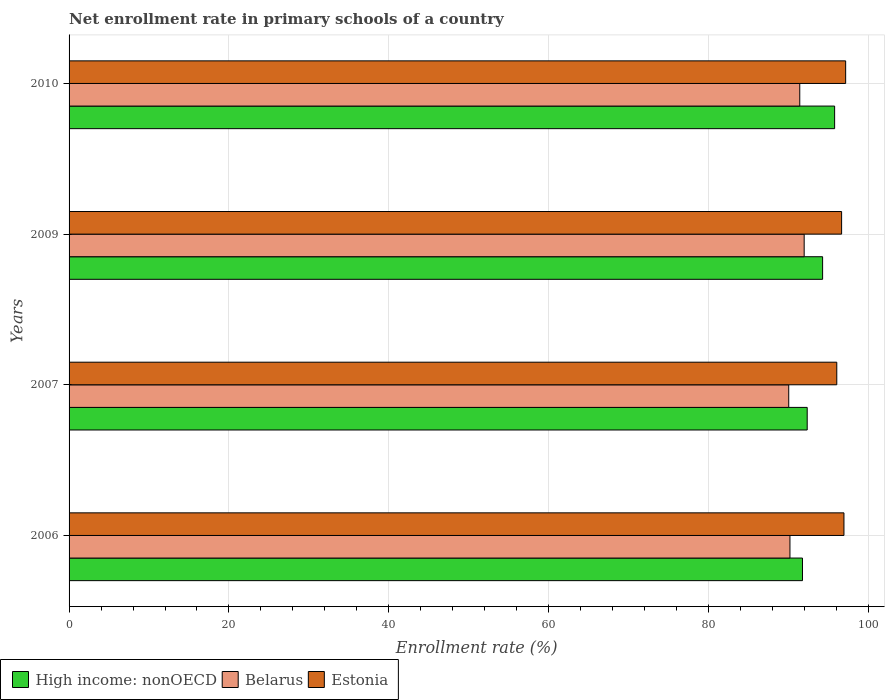Are the number of bars per tick equal to the number of legend labels?
Your response must be concise. Yes. How many bars are there on the 2nd tick from the bottom?
Give a very brief answer. 3. What is the label of the 3rd group of bars from the top?
Give a very brief answer. 2007. In how many cases, is the number of bars for a given year not equal to the number of legend labels?
Ensure brevity in your answer.  0. What is the enrollment rate in primary schools in Estonia in 2006?
Provide a short and direct response. 96.94. Across all years, what is the maximum enrollment rate in primary schools in Belarus?
Give a very brief answer. 91.96. Across all years, what is the minimum enrollment rate in primary schools in High income: nonOECD?
Make the answer very short. 91.75. In which year was the enrollment rate in primary schools in High income: nonOECD maximum?
Ensure brevity in your answer.  2010. In which year was the enrollment rate in primary schools in Belarus minimum?
Provide a succinct answer. 2007. What is the total enrollment rate in primary schools in Estonia in the graph?
Give a very brief answer. 386.77. What is the difference between the enrollment rate in primary schools in Belarus in 2006 and that in 2007?
Your response must be concise. 0.15. What is the difference between the enrollment rate in primary schools in Estonia in 2006 and the enrollment rate in primary schools in High income: nonOECD in 2010?
Ensure brevity in your answer.  1.17. What is the average enrollment rate in primary schools in High income: nonOECD per year?
Give a very brief answer. 93.53. In the year 2010, what is the difference between the enrollment rate in primary schools in Estonia and enrollment rate in primary schools in Belarus?
Provide a succinct answer. 5.74. What is the ratio of the enrollment rate in primary schools in Estonia in 2007 to that in 2009?
Ensure brevity in your answer.  0.99. What is the difference between the highest and the second highest enrollment rate in primary schools in High income: nonOECD?
Your answer should be very brief. 1.5. What is the difference between the highest and the lowest enrollment rate in primary schools in High income: nonOECD?
Offer a very short reply. 4.02. Is the sum of the enrollment rate in primary schools in High income: nonOECD in 2006 and 2007 greater than the maximum enrollment rate in primary schools in Belarus across all years?
Give a very brief answer. Yes. What does the 1st bar from the top in 2009 represents?
Provide a succinct answer. Estonia. What does the 1st bar from the bottom in 2010 represents?
Your answer should be compact. High income: nonOECD. Is it the case that in every year, the sum of the enrollment rate in primary schools in Belarus and enrollment rate in primary schools in High income: nonOECD is greater than the enrollment rate in primary schools in Estonia?
Provide a short and direct response. Yes. How many bars are there?
Your answer should be compact. 12. Are all the bars in the graph horizontal?
Give a very brief answer. Yes. Does the graph contain grids?
Provide a short and direct response. Yes. How many legend labels are there?
Give a very brief answer. 3. What is the title of the graph?
Your answer should be compact. Net enrollment rate in primary schools of a country. Does "Northern Mariana Islands" appear as one of the legend labels in the graph?
Offer a terse response. No. What is the label or title of the X-axis?
Ensure brevity in your answer.  Enrollment rate (%). What is the Enrollment rate (%) in High income: nonOECD in 2006?
Offer a very short reply. 91.75. What is the Enrollment rate (%) in Belarus in 2006?
Make the answer very short. 90.18. What is the Enrollment rate (%) of Estonia in 2006?
Your answer should be very brief. 96.94. What is the Enrollment rate (%) in High income: nonOECD in 2007?
Offer a terse response. 92.34. What is the Enrollment rate (%) of Belarus in 2007?
Provide a succinct answer. 90.03. What is the Enrollment rate (%) in Estonia in 2007?
Your answer should be very brief. 96.04. What is the Enrollment rate (%) of High income: nonOECD in 2009?
Ensure brevity in your answer.  94.27. What is the Enrollment rate (%) in Belarus in 2009?
Make the answer very short. 91.96. What is the Enrollment rate (%) in Estonia in 2009?
Make the answer very short. 96.64. What is the Enrollment rate (%) in High income: nonOECD in 2010?
Your answer should be very brief. 95.77. What is the Enrollment rate (%) in Belarus in 2010?
Offer a terse response. 91.41. What is the Enrollment rate (%) of Estonia in 2010?
Your answer should be very brief. 97.15. Across all years, what is the maximum Enrollment rate (%) of High income: nonOECD?
Offer a terse response. 95.77. Across all years, what is the maximum Enrollment rate (%) in Belarus?
Your response must be concise. 91.96. Across all years, what is the maximum Enrollment rate (%) of Estonia?
Your response must be concise. 97.15. Across all years, what is the minimum Enrollment rate (%) in High income: nonOECD?
Your answer should be very brief. 91.75. Across all years, what is the minimum Enrollment rate (%) in Belarus?
Keep it short and to the point. 90.03. Across all years, what is the minimum Enrollment rate (%) of Estonia?
Your answer should be very brief. 96.04. What is the total Enrollment rate (%) in High income: nonOECD in the graph?
Ensure brevity in your answer.  374.12. What is the total Enrollment rate (%) of Belarus in the graph?
Keep it short and to the point. 363.58. What is the total Enrollment rate (%) in Estonia in the graph?
Give a very brief answer. 386.77. What is the difference between the Enrollment rate (%) of High income: nonOECD in 2006 and that in 2007?
Make the answer very short. -0.59. What is the difference between the Enrollment rate (%) of Belarus in 2006 and that in 2007?
Keep it short and to the point. 0.15. What is the difference between the Enrollment rate (%) of Estonia in 2006 and that in 2007?
Keep it short and to the point. 0.9. What is the difference between the Enrollment rate (%) of High income: nonOECD in 2006 and that in 2009?
Offer a terse response. -2.52. What is the difference between the Enrollment rate (%) of Belarus in 2006 and that in 2009?
Provide a short and direct response. -1.78. What is the difference between the Enrollment rate (%) of Estonia in 2006 and that in 2009?
Provide a succinct answer. 0.29. What is the difference between the Enrollment rate (%) in High income: nonOECD in 2006 and that in 2010?
Your answer should be very brief. -4.02. What is the difference between the Enrollment rate (%) in Belarus in 2006 and that in 2010?
Make the answer very short. -1.23. What is the difference between the Enrollment rate (%) of Estonia in 2006 and that in 2010?
Your response must be concise. -0.21. What is the difference between the Enrollment rate (%) in High income: nonOECD in 2007 and that in 2009?
Offer a terse response. -1.93. What is the difference between the Enrollment rate (%) in Belarus in 2007 and that in 2009?
Your answer should be very brief. -1.93. What is the difference between the Enrollment rate (%) of Estonia in 2007 and that in 2009?
Your answer should be compact. -0.6. What is the difference between the Enrollment rate (%) of High income: nonOECD in 2007 and that in 2010?
Your response must be concise. -3.43. What is the difference between the Enrollment rate (%) in Belarus in 2007 and that in 2010?
Keep it short and to the point. -1.38. What is the difference between the Enrollment rate (%) in Estonia in 2007 and that in 2010?
Make the answer very short. -1.11. What is the difference between the Enrollment rate (%) of High income: nonOECD in 2009 and that in 2010?
Give a very brief answer. -1.5. What is the difference between the Enrollment rate (%) in Belarus in 2009 and that in 2010?
Your response must be concise. 0.55. What is the difference between the Enrollment rate (%) of Estonia in 2009 and that in 2010?
Keep it short and to the point. -0.51. What is the difference between the Enrollment rate (%) in High income: nonOECD in 2006 and the Enrollment rate (%) in Belarus in 2007?
Your answer should be very brief. 1.72. What is the difference between the Enrollment rate (%) in High income: nonOECD in 2006 and the Enrollment rate (%) in Estonia in 2007?
Make the answer very short. -4.29. What is the difference between the Enrollment rate (%) in Belarus in 2006 and the Enrollment rate (%) in Estonia in 2007?
Your answer should be compact. -5.86. What is the difference between the Enrollment rate (%) in High income: nonOECD in 2006 and the Enrollment rate (%) in Belarus in 2009?
Offer a very short reply. -0.21. What is the difference between the Enrollment rate (%) of High income: nonOECD in 2006 and the Enrollment rate (%) of Estonia in 2009?
Provide a short and direct response. -4.89. What is the difference between the Enrollment rate (%) of Belarus in 2006 and the Enrollment rate (%) of Estonia in 2009?
Provide a succinct answer. -6.46. What is the difference between the Enrollment rate (%) in High income: nonOECD in 2006 and the Enrollment rate (%) in Belarus in 2010?
Your response must be concise. 0.34. What is the difference between the Enrollment rate (%) of High income: nonOECD in 2006 and the Enrollment rate (%) of Estonia in 2010?
Give a very brief answer. -5.4. What is the difference between the Enrollment rate (%) in Belarus in 2006 and the Enrollment rate (%) in Estonia in 2010?
Keep it short and to the point. -6.97. What is the difference between the Enrollment rate (%) of High income: nonOECD in 2007 and the Enrollment rate (%) of Belarus in 2009?
Your answer should be very brief. 0.38. What is the difference between the Enrollment rate (%) of High income: nonOECD in 2007 and the Enrollment rate (%) of Estonia in 2009?
Give a very brief answer. -4.3. What is the difference between the Enrollment rate (%) of Belarus in 2007 and the Enrollment rate (%) of Estonia in 2009?
Keep it short and to the point. -6.61. What is the difference between the Enrollment rate (%) in High income: nonOECD in 2007 and the Enrollment rate (%) in Belarus in 2010?
Give a very brief answer. 0.93. What is the difference between the Enrollment rate (%) in High income: nonOECD in 2007 and the Enrollment rate (%) in Estonia in 2010?
Provide a short and direct response. -4.81. What is the difference between the Enrollment rate (%) in Belarus in 2007 and the Enrollment rate (%) in Estonia in 2010?
Give a very brief answer. -7.12. What is the difference between the Enrollment rate (%) in High income: nonOECD in 2009 and the Enrollment rate (%) in Belarus in 2010?
Offer a terse response. 2.86. What is the difference between the Enrollment rate (%) in High income: nonOECD in 2009 and the Enrollment rate (%) in Estonia in 2010?
Offer a terse response. -2.88. What is the difference between the Enrollment rate (%) of Belarus in 2009 and the Enrollment rate (%) of Estonia in 2010?
Ensure brevity in your answer.  -5.19. What is the average Enrollment rate (%) in High income: nonOECD per year?
Offer a very short reply. 93.53. What is the average Enrollment rate (%) in Belarus per year?
Provide a succinct answer. 90.89. What is the average Enrollment rate (%) of Estonia per year?
Your answer should be compact. 96.69. In the year 2006, what is the difference between the Enrollment rate (%) of High income: nonOECD and Enrollment rate (%) of Belarus?
Make the answer very short. 1.57. In the year 2006, what is the difference between the Enrollment rate (%) in High income: nonOECD and Enrollment rate (%) in Estonia?
Ensure brevity in your answer.  -5.19. In the year 2006, what is the difference between the Enrollment rate (%) in Belarus and Enrollment rate (%) in Estonia?
Make the answer very short. -6.76. In the year 2007, what is the difference between the Enrollment rate (%) of High income: nonOECD and Enrollment rate (%) of Belarus?
Provide a short and direct response. 2.31. In the year 2007, what is the difference between the Enrollment rate (%) in High income: nonOECD and Enrollment rate (%) in Estonia?
Your answer should be compact. -3.7. In the year 2007, what is the difference between the Enrollment rate (%) in Belarus and Enrollment rate (%) in Estonia?
Keep it short and to the point. -6.01. In the year 2009, what is the difference between the Enrollment rate (%) in High income: nonOECD and Enrollment rate (%) in Belarus?
Offer a terse response. 2.31. In the year 2009, what is the difference between the Enrollment rate (%) in High income: nonOECD and Enrollment rate (%) in Estonia?
Keep it short and to the point. -2.38. In the year 2009, what is the difference between the Enrollment rate (%) in Belarus and Enrollment rate (%) in Estonia?
Your answer should be very brief. -4.68. In the year 2010, what is the difference between the Enrollment rate (%) of High income: nonOECD and Enrollment rate (%) of Belarus?
Give a very brief answer. 4.36. In the year 2010, what is the difference between the Enrollment rate (%) in High income: nonOECD and Enrollment rate (%) in Estonia?
Offer a very short reply. -1.38. In the year 2010, what is the difference between the Enrollment rate (%) in Belarus and Enrollment rate (%) in Estonia?
Keep it short and to the point. -5.74. What is the ratio of the Enrollment rate (%) of High income: nonOECD in 2006 to that in 2007?
Make the answer very short. 0.99. What is the ratio of the Enrollment rate (%) in Estonia in 2006 to that in 2007?
Offer a terse response. 1.01. What is the ratio of the Enrollment rate (%) of High income: nonOECD in 2006 to that in 2009?
Offer a terse response. 0.97. What is the ratio of the Enrollment rate (%) of Belarus in 2006 to that in 2009?
Offer a very short reply. 0.98. What is the ratio of the Enrollment rate (%) in Estonia in 2006 to that in 2009?
Give a very brief answer. 1. What is the ratio of the Enrollment rate (%) in High income: nonOECD in 2006 to that in 2010?
Give a very brief answer. 0.96. What is the ratio of the Enrollment rate (%) in Belarus in 2006 to that in 2010?
Provide a short and direct response. 0.99. What is the ratio of the Enrollment rate (%) in High income: nonOECD in 2007 to that in 2009?
Your answer should be compact. 0.98. What is the ratio of the Enrollment rate (%) in Estonia in 2007 to that in 2009?
Keep it short and to the point. 0.99. What is the ratio of the Enrollment rate (%) in High income: nonOECD in 2007 to that in 2010?
Offer a very short reply. 0.96. What is the ratio of the Enrollment rate (%) in Belarus in 2007 to that in 2010?
Your answer should be compact. 0.98. What is the ratio of the Enrollment rate (%) of High income: nonOECD in 2009 to that in 2010?
Offer a very short reply. 0.98. What is the ratio of the Enrollment rate (%) of Belarus in 2009 to that in 2010?
Give a very brief answer. 1.01. What is the difference between the highest and the second highest Enrollment rate (%) in High income: nonOECD?
Ensure brevity in your answer.  1.5. What is the difference between the highest and the second highest Enrollment rate (%) in Belarus?
Offer a very short reply. 0.55. What is the difference between the highest and the second highest Enrollment rate (%) in Estonia?
Keep it short and to the point. 0.21. What is the difference between the highest and the lowest Enrollment rate (%) in High income: nonOECD?
Provide a succinct answer. 4.02. What is the difference between the highest and the lowest Enrollment rate (%) of Belarus?
Ensure brevity in your answer.  1.93. What is the difference between the highest and the lowest Enrollment rate (%) of Estonia?
Make the answer very short. 1.11. 